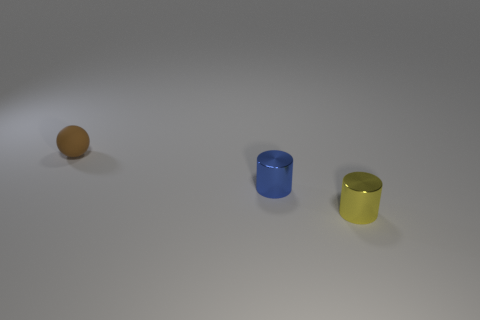What is the size of the blue cylinder on the left side of the yellow cylinder?
Provide a succinct answer. Small. Is the material of the yellow cylinder the same as the blue cylinder?
Your answer should be compact. Yes. There is a shiny thing on the right side of the tiny shiny cylinder that is to the left of the small yellow cylinder; are there any small shiny cylinders that are behind it?
Your response must be concise. Yes. What color is the sphere?
Your response must be concise. Brown. What color is the metallic object that is the same size as the yellow metallic cylinder?
Ensure brevity in your answer.  Blue. Is the shape of the thing right of the small blue thing the same as  the brown rubber thing?
Make the answer very short. No. What is the color of the tiny thing to the right of the tiny metallic object that is behind the tiny metallic cylinder that is on the right side of the blue object?
Your answer should be compact. Yellow. Are any cyan rubber blocks visible?
Offer a very short reply. No. How many other things are there of the same size as the rubber thing?
Offer a terse response. 2. What number of objects are either tiny cylinders or purple matte balls?
Give a very brief answer. 2. 